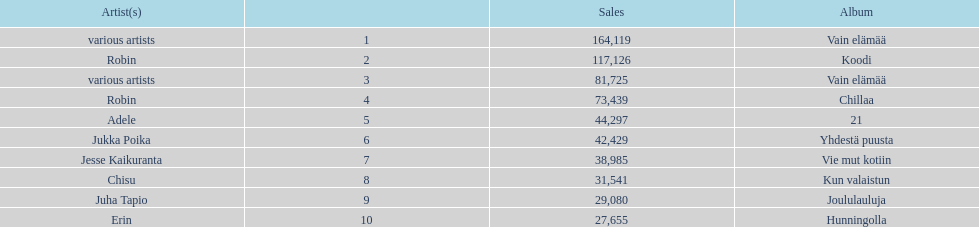Which album has the highest number of sales but doesn't have a designated artist? Vain elämää. 